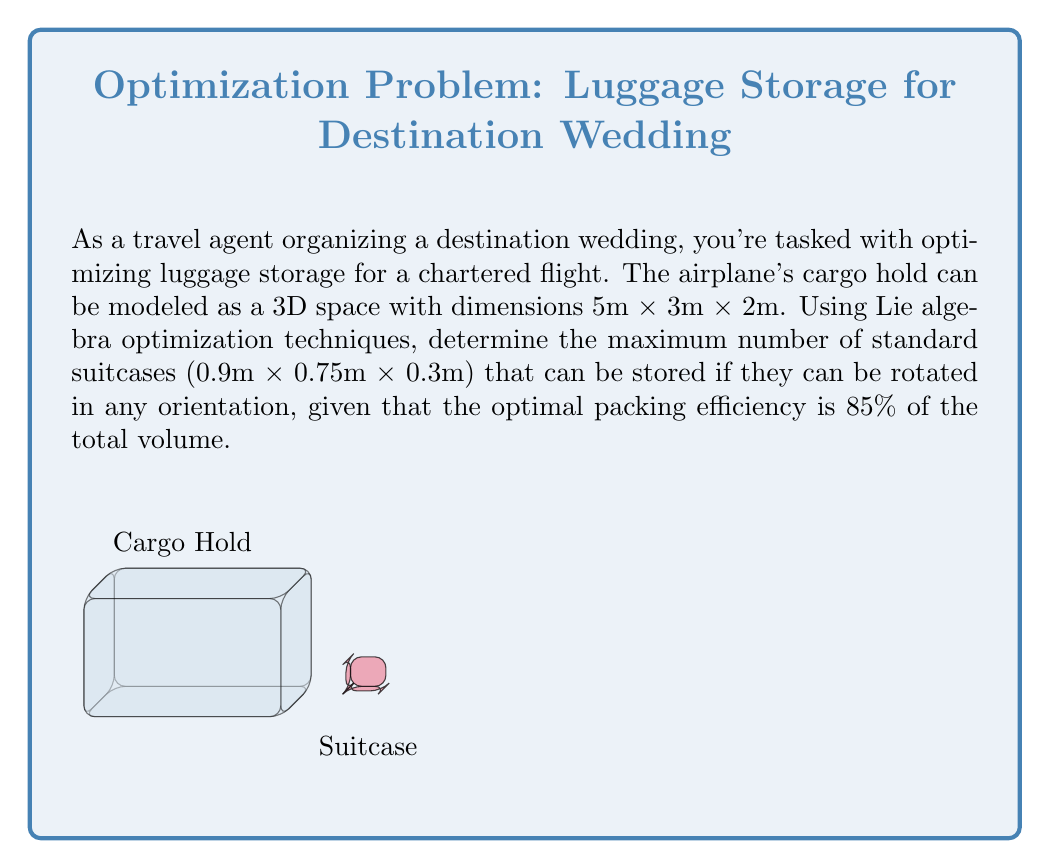What is the answer to this math problem? To solve this problem using Lie algebra optimization techniques, we'll follow these steps:

1) First, we need to calculate the total volume of the cargo hold:
   $$V_{cargo} = 5m \times 3m \times 2m = 30m^3$$

2) The volume of a single suitcase is:
   $$V_{suitcase} = 0.9m \times 0.75m \times 0.3m = 0.2025m^3$$

3) In Lie algebra, we can represent the rotation group SO(3) of 3D space. This allows us to consider all possible orientations of the suitcases. The optimal packing efficiency of 85% takes into account the space optimization achieved through these rotations.

4) The usable volume of the cargo hold, considering the 85% efficiency:
   $$V_{usable} = 0.85 \times 30m^3 = 25.5m^3$$

5) To find the maximum number of suitcases, we divide the usable volume by the volume of a single suitcase:
   $$N_{max} = \frac{V_{usable}}{V_{suitcase}} = \frac{25.5m^3}{0.2025m^3} \approx 125.93$$

6) Since we can't have a fractional number of suitcases, we round down to the nearest whole number.

The Lie algebra optimization allows for continuous rotations, ensuring that we can achieve the stated 85% efficiency by orienting the suitcases in the most space-efficient manner.
Answer: 125 suitcases 